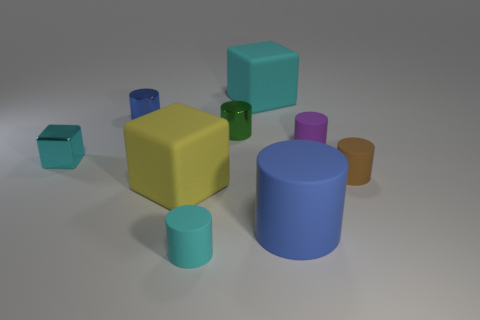There is a cyan matte object that is in front of the brown rubber thing; is it the same size as the cyan matte cube?
Offer a very short reply. No. Is there anything else that is the same shape as the large blue rubber object?
Your response must be concise. Yes. Is the material of the large yellow object the same as the blue object on the left side of the yellow cube?
Offer a very short reply. No. What number of blue things are large cylinders or cylinders?
Provide a short and direct response. 2. Are any small purple objects visible?
Keep it short and to the point. Yes. There is a blue thing that is to the left of the shiny thing that is right of the big yellow matte object; are there any blue metallic cylinders in front of it?
Keep it short and to the point. No. Are there any other things that are the same size as the brown matte cylinder?
Provide a short and direct response. Yes. There is a yellow rubber object; is its shape the same as the small cyan object behind the big yellow cube?
Keep it short and to the point. Yes. The large block that is on the left side of the cyan rubber thing to the right of the cyan rubber thing that is to the left of the big cyan matte thing is what color?
Offer a terse response. Yellow. What number of objects are either cyan rubber objects in front of the tiny blue cylinder or tiny cyan objects behind the big yellow rubber object?
Your answer should be very brief. 2. 